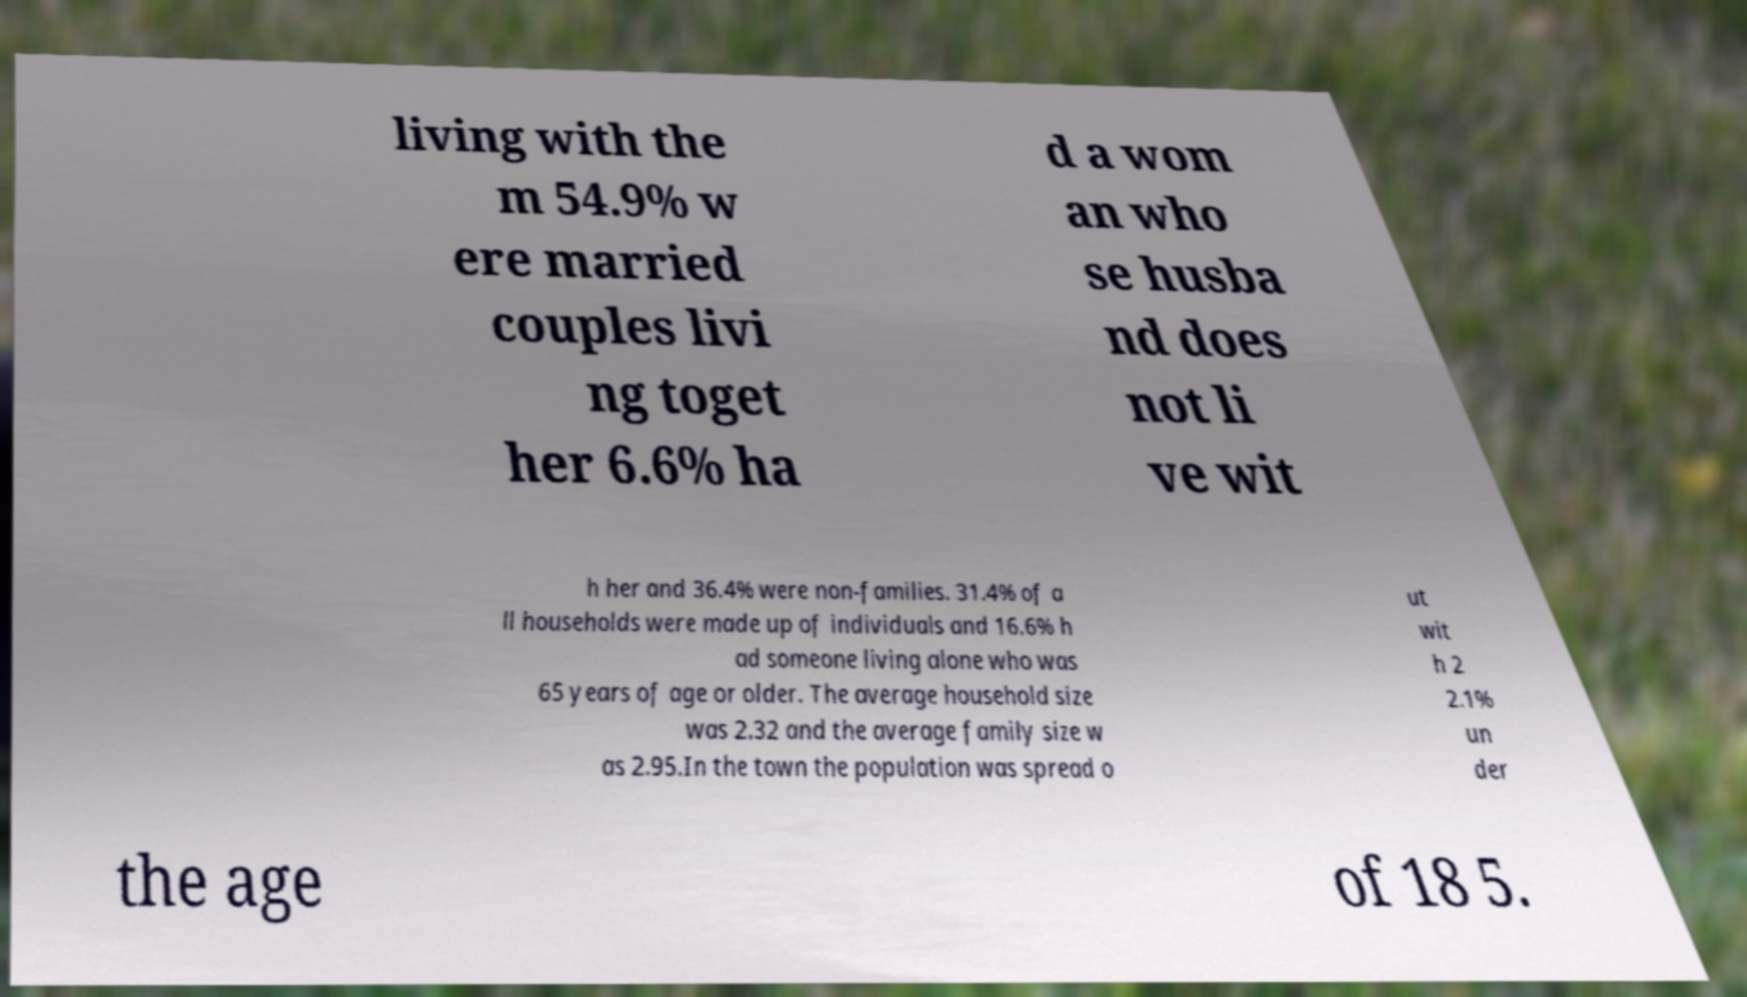I need the written content from this picture converted into text. Can you do that? living with the m 54.9% w ere married couples livi ng toget her 6.6% ha d a wom an who se husba nd does not li ve wit h her and 36.4% were non-families. 31.4% of a ll households were made up of individuals and 16.6% h ad someone living alone who was 65 years of age or older. The average household size was 2.32 and the average family size w as 2.95.In the town the population was spread o ut wit h 2 2.1% un der the age of 18 5. 